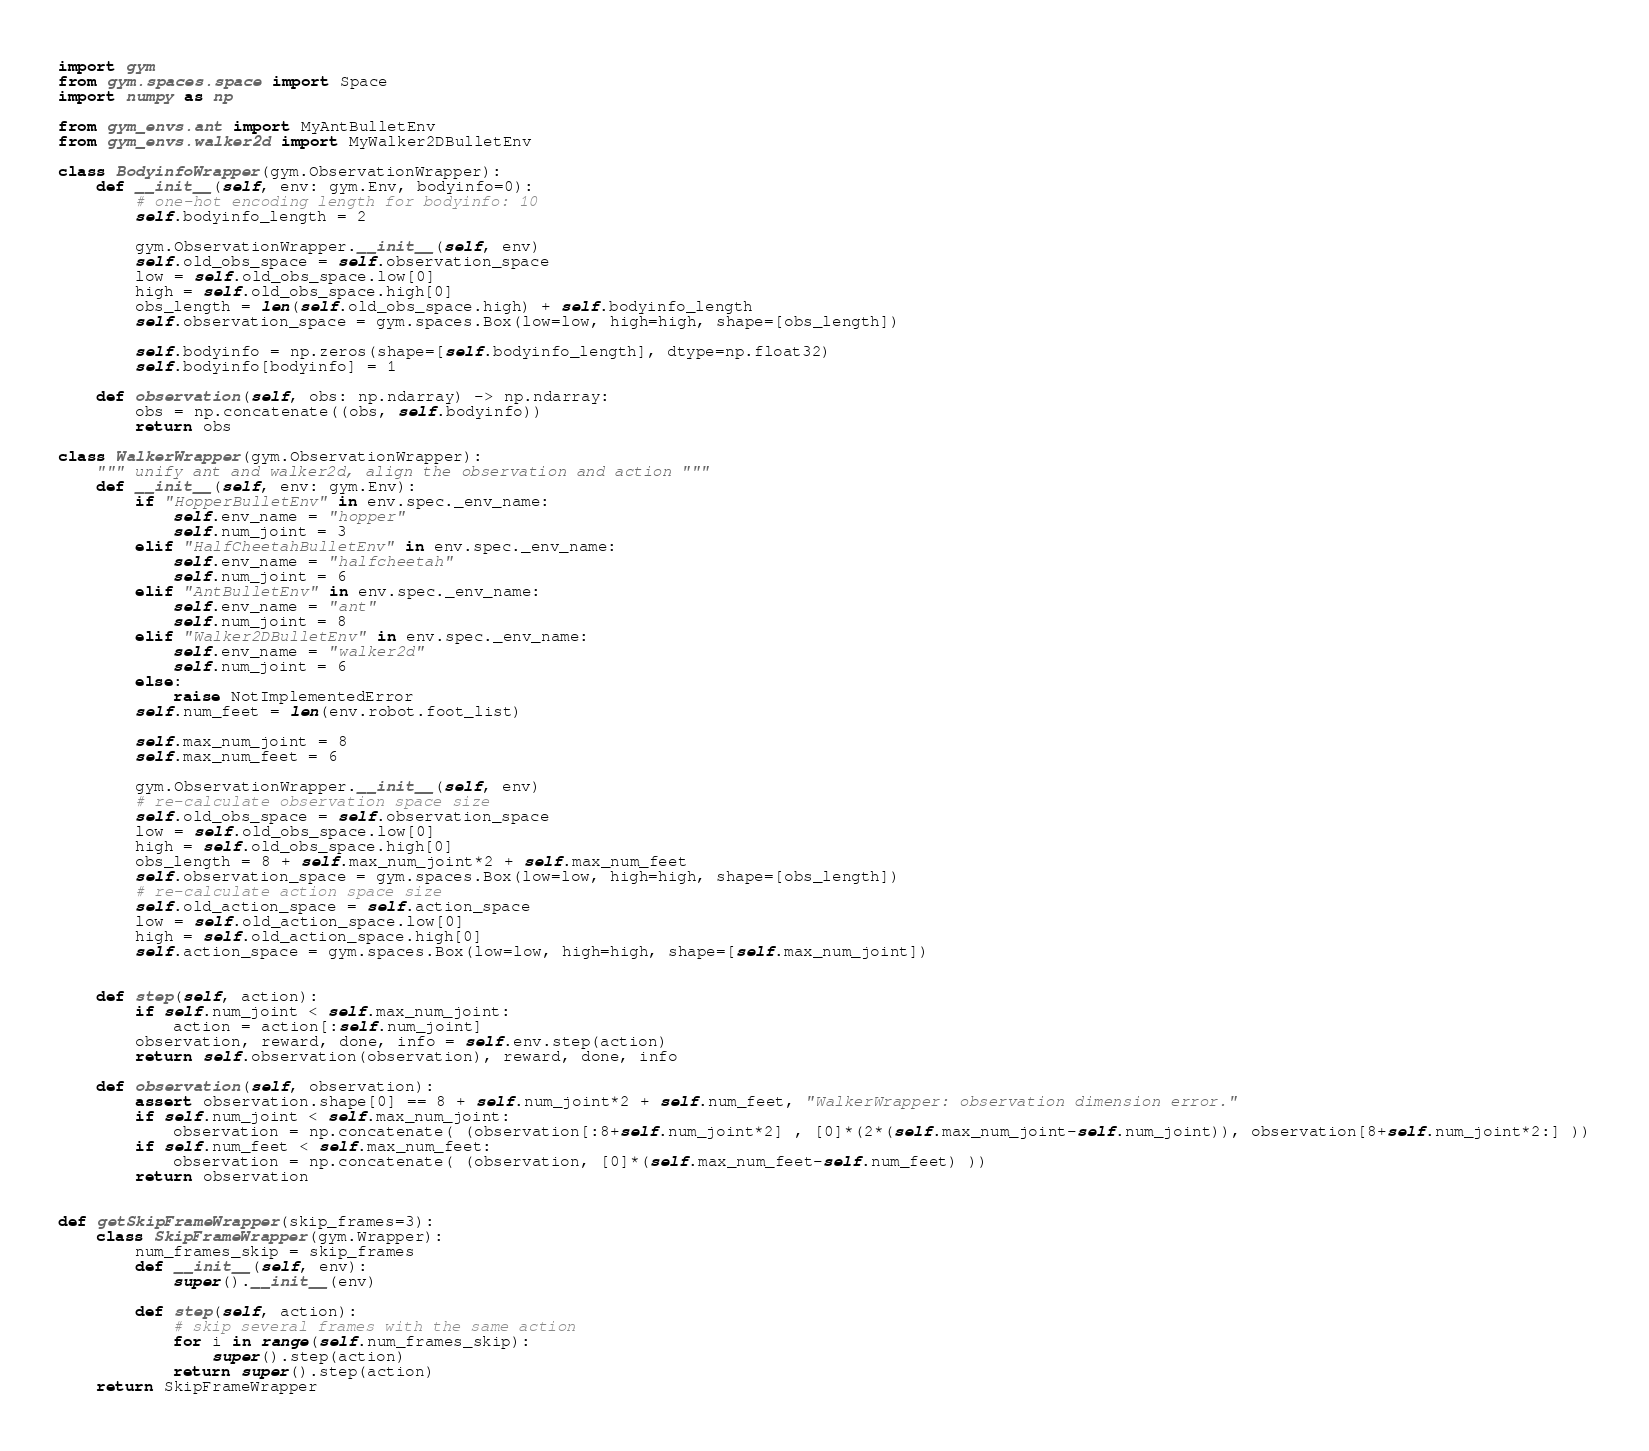Convert code to text. <code><loc_0><loc_0><loc_500><loc_500><_Python_>import gym
from gym.spaces.space import Space
import numpy as np

from gym_envs.ant import MyAntBulletEnv
from gym_envs.walker2d import MyWalker2DBulletEnv

class BodyinfoWrapper(gym.ObservationWrapper):
    def __init__(self, env: gym.Env, bodyinfo=0):
        # one-hot encoding length for bodyinfo: 10
        self.bodyinfo_length = 2

        gym.ObservationWrapper.__init__(self, env)
        self.old_obs_space = self.observation_space
        low = self.old_obs_space.low[0]
        high = self.old_obs_space.high[0]
        obs_length = len(self.old_obs_space.high) + self.bodyinfo_length
        self.observation_space = gym.spaces.Box(low=low, high=high, shape=[obs_length])

        self.bodyinfo = np.zeros(shape=[self.bodyinfo_length], dtype=np.float32)
        self.bodyinfo[bodyinfo] = 1

    def observation(self, obs: np.ndarray) -> np.ndarray:
        obs = np.concatenate((obs, self.bodyinfo))
        return obs

class WalkerWrapper(gym.ObservationWrapper):
    """ unify ant and walker2d, align the observation and action """
    def __init__(self, env: gym.Env):
        if "HopperBulletEnv" in env.spec._env_name:
            self.env_name = "hopper"
            self.num_joint = 3
        elif "HalfCheetahBulletEnv" in env.spec._env_name:
            self.env_name = "halfcheetah"
            self.num_joint = 6
        elif "AntBulletEnv" in env.spec._env_name:
            self.env_name = "ant"
            self.num_joint = 8
        elif "Walker2DBulletEnv" in env.spec._env_name:
            self.env_name = "walker2d"
            self.num_joint = 6
        else:
            raise NotImplementedError
        self.num_feet = len(env.robot.foot_list)

        self.max_num_joint = 8
        self.max_num_feet = 6

        gym.ObservationWrapper.__init__(self, env)
        # re-calculate observation space size
        self.old_obs_space = self.observation_space
        low = self.old_obs_space.low[0]
        high = self.old_obs_space.high[0]
        obs_length = 8 + self.max_num_joint*2 + self.max_num_feet
        self.observation_space = gym.spaces.Box(low=low, high=high, shape=[obs_length])
        # re-calculate action space size
        self.old_action_space = self.action_space
        low = self.old_action_space.low[0]
        high = self.old_action_space.high[0]
        self.action_space = gym.spaces.Box(low=low, high=high, shape=[self.max_num_joint])


    def step(self, action):
        if self.num_joint < self.max_num_joint:
            action = action[:self.num_joint]
        observation, reward, done, info = self.env.step(action)
        return self.observation(observation), reward, done, info

    def observation(self, observation):
        assert observation.shape[0] == 8 + self.num_joint*2 + self.num_feet, "WalkerWrapper: observation dimension error."
        if self.num_joint < self.max_num_joint:
            observation = np.concatenate( (observation[:8+self.num_joint*2] , [0]*(2*(self.max_num_joint-self.num_joint)), observation[8+self.num_joint*2:] ))
        if self.num_feet < self.max_num_feet:
            observation = np.concatenate( (observation, [0]*(self.max_num_feet-self.num_feet) ))
        return observation


def getSkipFrameWrapper(skip_frames=3):
    class SkipFrameWrapper(gym.Wrapper):
        num_frames_skip = skip_frames
        def __init__(self, env):
            super().__init__(env)
        
        def step(self, action):
            # skip several frames with the same action
            for i in range(self.num_frames_skip):
                super().step(action)
            return super().step(action)
    return SkipFrameWrapper</code> 